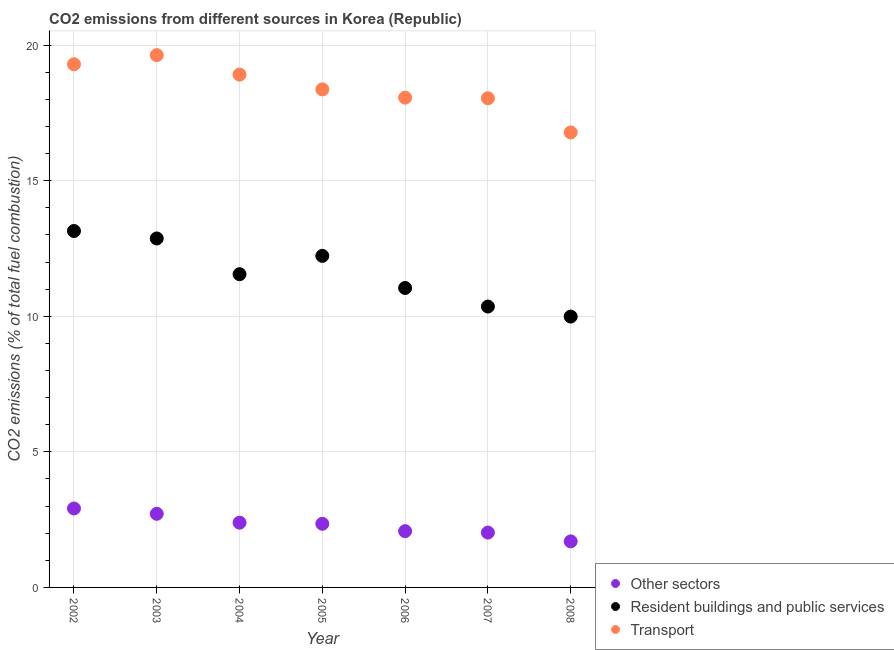How many different coloured dotlines are there?
Keep it short and to the point. 3. What is the percentage of co2 emissions from transport in 2008?
Offer a terse response. 16.78. Across all years, what is the maximum percentage of co2 emissions from transport?
Give a very brief answer. 19.63. Across all years, what is the minimum percentage of co2 emissions from other sectors?
Your answer should be very brief. 1.7. In which year was the percentage of co2 emissions from other sectors minimum?
Your answer should be compact. 2008. What is the total percentage of co2 emissions from transport in the graph?
Provide a short and direct response. 129.08. What is the difference between the percentage of co2 emissions from other sectors in 2006 and that in 2007?
Your answer should be compact. 0.05. What is the difference between the percentage of co2 emissions from other sectors in 2006 and the percentage of co2 emissions from resident buildings and public services in 2005?
Your response must be concise. -10.15. What is the average percentage of co2 emissions from resident buildings and public services per year?
Offer a very short reply. 11.6. In the year 2003, what is the difference between the percentage of co2 emissions from other sectors and percentage of co2 emissions from transport?
Ensure brevity in your answer.  -16.91. In how many years, is the percentage of co2 emissions from other sectors greater than 6 %?
Provide a succinct answer. 0. What is the ratio of the percentage of co2 emissions from resident buildings and public services in 2002 to that in 2005?
Give a very brief answer. 1.07. What is the difference between the highest and the second highest percentage of co2 emissions from other sectors?
Keep it short and to the point. 0.2. What is the difference between the highest and the lowest percentage of co2 emissions from transport?
Provide a succinct answer. 2.85. Is the sum of the percentage of co2 emissions from resident buildings and public services in 2004 and 2006 greater than the maximum percentage of co2 emissions from other sectors across all years?
Give a very brief answer. Yes. Is it the case that in every year, the sum of the percentage of co2 emissions from other sectors and percentage of co2 emissions from resident buildings and public services is greater than the percentage of co2 emissions from transport?
Make the answer very short. No. Is the percentage of co2 emissions from transport strictly greater than the percentage of co2 emissions from other sectors over the years?
Your response must be concise. Yes. How many years are there in the graph?
Provide a short and direct response. 7. How many legend labels are there?
Your answer should be compact. 3. What is the title of the graph?
Your answer should be compact. CO2 emissions from different sources in Korea (Republic). Does "Services" appear as one of the legend labels in the graph?
Your response must be concise. No. What is the label or title of the Y-axis?
Offer a terse response. CO2 emissions (% of total fuel combustion). What is the CO2 emissions (% of total fuel combustion) of Other sectors in 2002?
Offer a terse response. 2.91. What is the CO2 emissions (% of total fuel combustion) in Resident buildings and public services in 2002?
Keep it short and to the point. 13.14. What is the CO2 emissions (% of total fuel combustion) in Transport in 2002?
Your answer should be compact. 19.29. What is the CO2 emissions (% of total fuel combustion) in Other sectors in 2003?
Ensure brevity in your answer.  2.72. What is the CO2 emissions (% of total fuel combustion) of Resident buildings and public services in 2003?
Your answer should be very brief. 12.87. What is the CO2 emissions (% of total fuel combustion) in Transport in 2003?
Offer a terse response. 19.63. What is the CO2 emissions (% of total fuel combustion) in Other sectors in 2004?
Offer a very short reply. 2.39. What is the CO2 emissions (% of total fuel combustion) in Resident buildings and public services in 2004?
Your answer should be compact. 11.55. What is the CO2 emissions (% of total fuel combustion) of Transport in 2004?
Your answer should be compact. 18.91. What is the CO2 emissions (% of total fuel combustion) of Other sectors in 2005?
Keep it short and to the point. 2.35. What is the CO2 emissions (% of total fuel combustion) of Resident buildings and public services in 2005?
Your response must be concise. 12.23. What is the CO2 emissions (% of total fuel combustion) of Transport in 2005?
Your answer should be compact. 18.37. What is the CO2 emissions (% of total fuel combustion) of Other sectors in 2006?
Your response must be concise. 2.07. What is the CO2 emissions (% of total fuel combustion) of Resident buildings and public services in 2006?
Provide a short and direct response. 11.04. What is the CO2 emissions (% of total fuel combustion) of Transport in 2006?
Offer a terse response. 18.06. What is the CO2 emissions (% of total fuel combustion) in Other sectors in 2007?
Keep it short and to the point. 2.02. What is the CO2 emissions (% of total fuel combustion) in Resident buildings and public services in 2007?
Your answer should be very brief. 10.36. What is the CO2 emissions (% of total fuel combustion) of Transport in 2007?
Your answer should be very brief. 18.04. What is the CO2 emissions (% of total fuel combustion) of Other sectors in 2008?
Your answer should be compact. 1.7. What is the CO2 emissions (% of total fuel combustion) in Resident buildings and public services in 2008?
Keep it short and to the point. 9.99. What is the CO2 emissions (% of total fuel combustion) of Transport in 2008?
Your response must be concise. 16.78. Across all years, what is the maximum CO2 emissions (% of total fuel combustion) in Other sectors?
Your answer should be compact. 2.91. Across all years, what is the maximum CO2 emissions (% of total fuel combustion) in Resident buildings and public services?
Provide a succinct answer. 13.14. Across all years, what is the maximum CO2 emissions (% of total fuel combustion) in Transport?
Provide a succinct answer. 19.63. Across all years, what is the minimum CO2 emissions (% of total fuel combustion) in Other sectors?
Make the answer very short. 1.7. Across all years, what is the minimum CO2 emissions (% of total fuel combustion) in Resident buildings and public services?
Your answer should be compact. 9.99. Across all years, what is the minimum CO2 emissions (% of total fuel combustion) in Transport?
Ensure brevity in your answer.  16.78. What is the total CO2 emissions (% of total fuel combustion) in Other sectors in the graph?
Keep it short and to the point. 16.16. What is the total CO2 emissions (% of total fuel combustion) of Resident buildings and public services in the graph?
Provide a succinct answer. 81.18. What is the total CO2 emissions (% of total fuel combustion) in Transport in the graph?
Offer a terse response. 129.08. What is the difference between the CO2 emissions (% of total fuel combustion) in Other sectors in 2002 and that in 2003?
Make the answer very short. 0.2. What is the difference between the CO2 emissions (% of total fuel combustion) in Resident buildings and public services in 2002 and that in 2003?
Give a very brief answer. 0.28. What is the difference between the CO2 emissions (% of total fuel combustion) in Transport in 2002 and that in 2003?
Your response must be concise. -0.34. What is the difference between the CO2 emissions (% of total fuel combustion) of Other sectors in 2002 and that in 2004?
Ensure brevity in your answer.  0.52. What is the difference between the CO2 emissions (% of total fuel combustion) in Resident buildings and public services in 2002 and that in 2004?
Provide a succinct answer. 1.59. What is the difference between the CO2 emissions (% of total fuel combustion) in Transport in 2002 and that in 2004?
Give a very brief answer. 0.38. What is the difference between the CO2 emissions (% of total fuel combustion) of Other sectors in 2002 and that in 2005?
Keep it short and to the point. 0.56. What is the difference between the CO2 emissions (% of total fuel combustion) of Resident buildings and public services in 2002 and that in 2005?
Your response must be concise. 0.92. What is the difference between the CO2 emissions (% of total fuel combustion) of Transport in 2002 and that in 2005?
Provide a succinct answer. 0.93. What is the difference between the CO2 emissions (% of total fuel combustion) in Other sectors in 2002 and that in 2006?
Your answer should be compact. 0.84. What is the difference between the CO2 emissions (% of total fuel combustion) of Resident buildings and public services in 2002 and that in 2006?
Make the answer very short. 2.1. What is the difference between the CO2 emissions (% of total fuel combustion) of Transport in 2002 and that in 2006?
Make the answer very short. 1.23. What is the difference between the CO2 emissions (% of total fuel combustion) in Other sectors in 2002 and that in 2007?
Give a very brief answer. 0.89. What is the difference between the CO2 emissions (% of total fuel combustion) of Resident buildings and public services in 2002 and that in 2007?
Ensure brevity in your answer.  2.79. What is the difference between the CO2 emissions (% of total fuel combustion) of Transport in 2002 and that in 2007?
Provide a short and direct response. 1.25. What is the difference between the CO2 emissions (% of total fuel combustion) of Other sectors in 2002 and that in 2008?
Offer a terse response. 1.21. What is the difference between the CO2 emissions (% of total fuel combustion) of Resident buildings and public services in 2002 and that in 2008?
Make the answer very short. 3.16. What is the difference between the CO2 emissions (% of total fuel combustion) in Transport in 2002 and that in 2008?
Make the answer very short. 2.51. What is the difference between the CO2 emissions (% of total fuel combustion) of Other sectors in 2003 and that in 2004?
Offer a very short reply. 0.33. What is the difference between the CO2 emissions (% of total fuel combustion) of Resident buildings and public services in 2003 and that in 2004?
Keep it short and to the point. 1.32. What is the difference between the CO2 emissions (% of total fuel combustion) in Transport in 2003 and that in 2004?
Your answer should be compact. 0.72. What is the difference between the CO2 emissions (% of total fuel combustion) in Other sectors in 2003 and that in 2005?
Your answer should be very brief. 0.37. What is the difference between the CO2 emissions (% of total fuel combustion) of Resident buildings and public services in 2003 and that in 2005?
Your answer should be very brief. 0.64. What is the difference between the CO2 emissions (% of total fuel combustion) in Transport in 2003 and that in 2005?
Offer a very short reply. 1.26. What is the difference between the CO2 emissions (% of total fuel combustion) in Other sectors in 2003 and that in 2006?
Make the answer very short. 0.64. What is the difference between the CO2 emissions (% of total fuel combustion) of Resident buildings and public services in 2003 and that in 2006?
Make the answer very short. 1.83. What is the difference between the CO2 emissions (% of total fuel combustion) in Transport in 2003 and that in 2006?
Give a very brief answer. 1.57. What is the difference between the CO2 emissions (% of total fuel combustion) of Other sectors in 2003 and that in 2007?
Your answer should be compact. 0.69. What is the difference between the CO2 emissions (% of total fuel combustion) in Resident buildings and public services in 2003 and that in 2007?
Offer a very short reply. 2.51. What is the difference between the CO2 emissions (% of total fuel combustion) of Transport in 2003 and that in 2007?
Your answer should be very brief. 1.59. What is the difference between the CO2 emissions (% of total fuel combustion) in Other sectors in 2003 and that in 2008?
Give a very brief answer. 1.02. What is the difference between the CO2 emissions (% of total fuel combustion) in Resident buildings and public services in 2003 and that in 2008?
Provide a short and direct response. 2.88. What is the difference between the CO2 emissions (% of total fuel combustion) of Transport in 2003 and that in 2008?
Your response must be concise. 2.85. What is the difference between the CO2 emissions (% of total fuel combustion) of Other sectors in 2004 and that in 2005?
Offer a very short reply. 0.04. What is the difference between the CO2 emissions (% of total fuel combustion) in Resident buildings and public services in 2004 and that in 2005?
Ensure brevity in your answer.  -0.68. What is the difference between the CO2 emissions (% of total fuel combustion) in Transport in 2004 and that in 2005?
Your response must be concise. 0.55. What is the difference between the CO2 emissions (% of total fuel combustion) of Other sectors in 2004 and that in 2006?
Give a very brief answer. 0.31. What is the difference between the CO2 emissions (% of total fuel combustion) in Resident buildings and public services in 2004 and that in 2006?
Offer a very short reply. 0.51. What is the difference between the CO2 emissions (% of total fuel combustion) of Transport in 2004 and that in 2006?
Your answer should be very brief. 0.85. What is the difference between the CO2 emissions (% of total fuel combustion) in Other sectors in 2004 and that in 2007?
Provide a succinct answer. 0.37. What is the difference between the CO2 emissions (% of total fuel combustion) in Resident buildings and public services in 2004 and that in 2007?
Your response must be concise. 1.19. What is the difference between the CO2 emissions (% of total fuel combustion) in Transport in 2004 and that in 2007?
Offer a terse response. 0.87. What is the difference between the CO2 emissions (% of total fuel combustion) of Other sectors in 2004 and that in 2008?
Your answer should be compact. 0.69. What is the difference between the CO2 emissions (% of total fuel combustion) in Resident buildings and public services in 2004 and that in 2008?
Make the answer very short. 1.56. What is the difference between the CO2 emissions (% of total fuel combustion) of Transport in 2004 and that in 2008?
Your answer should be compact. 2.13. What is the difference between the CO2 emissions (% of total fuel combustion) in Other sectors in 2005 and that in 2006?
Offer a very short reply. 0.27. What is the difference between the CO2 emissions (% of total fuel combustion) of Resident buildings and public services in 2005 and that in 2006?
Your answer should be compact. 1.18. What is the difference between the CO2 emissions (% of total fuel combustion) of Transport in 2005 and that in 2006?
Your answer should be very brief. 0.3. What is the difference between the CO2 emissions (% of total fuel combustion) in Other sectors in 2005 and that in 2007?
Your answer should be very brief. 0.32. What is the difference between the CO2 emissions (% of total fuel combustion) in Resident buildings and public services in 2005 and that in 2007?
Make the answer very short. 1.87. What is the difference between the CO2 emissions (% of total fuel combustion) in Transport in 2005 and that in 2007?
Provide a succinct answer. 0.33. What is the difference between the CO2 emissions (% of total fuel combustion) in Other sectors in 2005 and that in 2008?
Your answer should be compact. 0.65. What is the difference between the CO2 emissions (% of total fuel combustion) in Resident buildings and public services in 2005 and that in 2008?
Provide a short and direct response. 2.24. What is the difference between the CO2 emissions (% of total fuel combustion) of Transport in 2005 and that in 2008?
Offer a very short reply. 1.59. What is the difference between the CO2 emissions (% of total fuel combustion) of Other sectors in 2006 and that in 2007?
Give a very brief answer. 0.05. What is the difference between the CO2 emissions (% of total fuel combustion) in Resident buildings and public services in 2006 and that in 2007?
Offer a terse response. 0.68. What is the difference between the CO2 emissions (% of total fuel combustion) of Transport in 2006 and that in 2007?
Your response must be concise. 0.02. What is the difference between the CO2 emissions (% of total fuel combustion) of Other sectors in 2006 and that in 2008?
Keep it short and to the point. 0.38. What is the difference between the CO2 emissions (% of total fuel combustion) in Resident buildings and public services in 2006 and that in 2008?
Your answer should be compact. 1.05. What is the difference between the CO2 emissions (% of total fuel combustion) in Transport in 2006 and that in 2008?
Provide a succinct answer. 1.28. What is the difference between the CO2 emissions (% of total fuel combustion) of Other sectors in 2007 and that in 2008?
Provide a short and direct response. 0.32. What is the difference between the CO2 emissions (% of total fuel combustion) in Resident buildings and public services in 2007 and that in 2008?
Your answer should be very brief. 0.37. What is the difference between the CO2 emissions (% of total fuel combustion) of Transport in 2007 and that in 2008?
Make the answer very short. 1.26. What is the difference between the CO2 emissions (% of total fuel combustion) in Other sectors in 2002 and the CO2 emissions (% of total fuel combustion) in Resident buildings and public services in 2003?
Your response must be concise. -9.96. What is the difference between the CO2 emissions (% of total fuel combustion) of Other sectors in 2002 and the CO2 emissions (% of total fuel combustion) of Transport in 2003?
Ensure brevity in your answer.  -16.72. What is the difference between the CO2 emissions (% of total fuel combustion) of Resident buildings and public services in 2002 and the CO2 emissions (% of total fuel combustion) of Transport in 2003?
Ensure brevity in your answer.  -6.49. What is the difference between the CO2 emissions (% of total fuel combustion) of Other sectors in 2002 and the CO2 emissions (% of total fuel combustion) of Resident buildings and public services in 2004?
Give a very brief answer. -8.64. What is the difference between the CO2 emissions (% of total fuel combustion) in Other sectors in 2002 and the CO2 emissions (% of total fuel combustion) in Transport in 2004?
Your answer should be compact. -16. What is the difference between the CO2 emissions (% of total fuel combustion) in Resident buildings and public services in 2002 and the CO2 emissions (% of total fuel combustion) in Transport in 2004?
Your answer should be compact. -5.77. What is the difference between the CO2 emissions (% of total fuel combustion) of Other sectors in 2002 and the CO2 emissions (% of total fuel combustion) of Resident buildings and public services in 2005?
Offer a terse response. -9.32. What is the difference between the CO2 emissions (% of total fuel combustion) in Other sectors in 2002 and the CO2 emissions (% of total fuel combustion) in Transport in 2005?
Your answer should be compact. -15.45. What is the difference between the CO2 emissions (% of total fuel combustion) of Resident buildings and public services in 2002 and the CO2 emissions (% of total fuel combustion) of Transport in 2005?
Provide a short and direct response. -5.22. What is the difference between the CO2 emissions (% of total fuel combustion) of Other sectors in 2002 and the CO2 emissions (% of total fuel combustion) of Resident buildings and public services in 2006?
Your answer should be compact. -8.13. What is the difference between the CO2 emissions (% of total fuel combustion) in Other sectors in 2002 and the CO2 emissions (% of total fuel combustion) in Transport in 2006?
Provide a short and direct response. -15.15. What is the difference between the CO2 emissions (% of total fuel combustion) in Resident buildings and public services in 2002 and the CO2 emissions (% of total fuel combustion) in Transport in 2006?
Your answer should be compact. -4.92. What is the difference between the CO2 emissions (% of total fuel combustion) of Other sectors in 2002 and the CO2 emissions (% of total fuel combustion) of Resident buildings and public services in 2007?
Keep it short and to the point. -7.45. What is the difference between the CO2 emissions (% of total fuel combustion) of Other sectors in 2002 and the CO2 emissions (% of total fuel combustion) of Transport in 2007?
Your answer should be very brief. -15.13. What is the difference between the CO2 emissions (% of total fuel combustion) of Resident buildings and public services in 2002 and the CO2 emissions (% of total fuel combustion) of Transport in 2007?
Give a very brief answer. -4.9. What is the difference between the CO2 emissions (% of total fuel combustion) in Other sectors in 2002 and the CO2 emissions (% of total fuel combustion) in Resident buildings and public services in 2008?
Your answer should be very brief. -7.08. What is the difference between the CO2 emissions (% of total fuel combustion) of Other sectors in 2002 and the CO2 emissions (% of total fuel combustion) of Transport in 2008?
Give a very brief answer. -13.87. What is the difference between the CO2 emissions (% of total fuel combustion) of Resident buildings and public services in 2002 and the CO2 emissions (% of total fuel combustion) of Transport in 2008?
Your answer should be compact. -3.63. What is the difference between the CO2 emissions (% of total fuel combustion) of Other sectors in 2003 and the CO2 emissions (% of total fuel combustion) of Resident buildings and public services in 2004?
Keep it short and to the point. -8.84. What is the difference between the CO2 emissions (% of total fuel combustion) of Other sectors in 2003 and the CO2 emissions (% of total fuel combustion) of Transport in 2004?
Your answer should be compact. -16.2. What is the difference between the CO2 emissions (% of total fuel combustion) in Resident buildings and public services in 2003 and the CO2 emissions (% of total fuel combustion) in Transport in 2004?
Offer a terse response. -6.04. What is the difference between the CO2 emissions (% of total fuel combustion) of Other sectors in 2003 and the CO2 emissions (% of total fuel combustion) of Resident buildings and public services in 2005?
Make the answer very short. -9.51. What is the difference between the CO2 emissions (% of total fuel combustion) in Other sectors in 2003 and the CO2 emissions (% of total fuel combustion) in Transport in 2005?
Keep it short and to the point. -15.65. What is the difference between the CO2 emissions (% of total fuel combustion) in Resident buildings and public services in 2003 and the CO2 emissions (% of total fuel combustion) in Transport in 2005?
Make the answer very short. -5.5. What is the difference between the CO2 emissions (% of total fuel combustion) of Other sectors in 2003 and the CO2 emissions (% of total fuel combustion) of Resident buildings and public services in 2006?
Ensure brevity in your answer.  -8.33. What is the difference between the CO2 emissions (% of total fuel combustion) in Other sectors in 2003 and the CO2 emissions (% of total fuel combustion) in Transport in 2006?
Your answer should be compact. -15.35. What is the difference between the CO2 emissions (% of total fuel combustion) of Resident buildings and public services in 2003 and the CO2 emissions (% of total fuel combustion) of Transport in 2006?
Make the answer very short. -5.19. What is the difference between the CO2 emissions (% of total fuel combustion) of Other sectors in 2003 and the CO2 emissions (% of total fuel combustion) of Resident buildings and public services in 2007?
Make the answer very short. -7.64. What is the difference between the CO2 emissions (% of total fuel combustion) of Other sectors in 2003 and the CO2 emissions (% of total fuel combustion) of Transport in 2007?
Make the answer very short. -15.32. What is the difference between the CO2 emissions (% of total fuel combustion) in Resident buildings and public services in 2003 and the CO2 emissions (% of total fuel combustion) in Transport in 2007?
Offer a terse response. -5.17. What is the difference between the CO2 emissions (% of total fuel combustion) in Other sectors in 2003 and the CO2 emissions (% of total fuel combustion) in Resident buildings and public services in 2008?
Offer a very short reply. -7.27. What is the difference between the CO2 emissions (% of total fuel combustion) in Other sectors in 2003 and the CO2 emissions (% of total fuel combustion) in Transport in 2008?
Offer a terse response. -14.06. What is the difference between the CO2 emissions (% of total fuel combustion) of Resident buildings and public services in 2003 and the CO2 emissions (% of total fuel combustion) of Transport in 2008?
Offer a very short reply. -3.91. What is the difference between the CO2 emissions (% of total fuel combustion) in Other sectors in 2004 and the CO2 emissions (% of total fuel combustion) in Resident buildings and public services in 2005?
Provide a succinct answer. -9.84. What is the difference between the CO2 emissions (% of total fuel combustion) of Other sectors in 2004 and the CO2 emissions (% of total fuel combustion) of Transport in 2005?
Make the answer very short. -15.98. What is the difference between the CO2 emissions (% of total fuel combustion) in Resident buildings and public services in 2004 and the CO2 emissions (% of total fuel combustion) in Transport in 2005?
Your response must be concise. -6.82. What is the difference between the CO2 emissions (% of total fuel combustion) in Other sectors in 2004 and the CO2 emissions (% of total fuel combustion) in Resident buildings and public services in 2006?
Ensure brevity in your answer.  -8.65. What is the difference between the CO2 emissions (% of total fuel combustion) in Other sectors in 2004 and the CO2 emissions (% of total fuel combustion) in Transport in 2006?
Your answer should be compact. -15.67. What is the difference between the CO2 emissions (% of total fuel combustion) of Resident buildings and public services in 2004 and the CO2 emissions (% of total fuel combustion) of Transport in 2006?
Make the answer very short. -6.51. What is the difference between the CO2 emissions (% of total fuel combustion) of Other sectors in 2004 and the CO2 emissions (% of total fuel combustion) of Resident buildings and public services in 2007?
Keep it short and to the point. -7.97. What is the difference between the CO2 emissions (% of total fuel combustion) in Other sectors in 2004 and the CO2 emissions (% of total fuel combustion) in Transport in 2007?
Make the answer very short. -15.65. What is the difference between the CO2 emissions (% of total fuel combustion) in Resident buildings and public services in 2004 and the CO2 emissions (% of total fuel combustion) in Transport in 2007?
Make the answer very short. -6.49. What is the difference between the CO2 emissions (% of total fuel combustion) of Other sectors in 2004 and the CO2 emissions (% of total fuel combustion) of Resident buildings and public services in 2008?
Offer a very short reply. -7.6. What is the difference between the CO2 emissions (% of total fuel combustion) in Other sectors in 2004 and the CO2 emissions (% of total fuel combustion) in Transport in 2008?
Provide a short and direct response. -14.39. What is the difference between the CO2 emissions (% of total fuel combustion) of Resident buildings and public services in 2004 and the CO2 emissions (% of total fuel combustion) of Transport in 2008?
Offer a terse response. -5.23. What is the difference between the CO2 emissions (% of total fuel combustion) of Other sectors in 2005 and the CO2 emissions (% of total fuel combustion) of Resident buildings and public services in 2006?
Offer a terse response. -8.7. What is the difference between the CO2 emissions (% of total fuel combustion) of Other sectors in 2005 and the CO2 emissions (% of total fuel combustion) of Transport in 2006?
Provide a short and direct response. -15.72. What is the difference between the CO2 emissions (% of total fuel combustion) of Resident buildings and public services in 2005 and the CO2 emissions (% of total fuel combustion) of Transport in 2006?
Provide a short and direct response. -5.83. What is the difference between the CO2 emissions (% of total fuel combustion) of Other sectors in 2005 and the CO2 emissions (% of total fuel combustion) of Resident buildings and public services in 2007?
Keep it short and to the point. -8.01. What is the difference between the CO2 emissions (% of total fuel combustion) of Other sectors in 2005 and the CO2 emissions (% of total fuel combustion) of Transport in 2007?
Ensure brevity in your answer.  -15.69. What is the difference between the CO2 emissions (% of total fuel combustion) in Resident buildings and public services in 2005 and the CO2 emissions (% of total fuel combustion) in Transport in 2007?
Your answer should be very brief. -5.81. What is the difference between the CO2 emissions (% of total fuel combustion) of Other sectors in 2005 and the CO2 emissions (% of total fuel combustion) of Resident buildings and public services in 2008?
Your answer should be compact. -7.64. What is the difference between the CO2 emissions (% of total fuel combustion) of Other sectors in 2005 and the CO2 emissions (% of total fuel combustion) of Transport in 2008?
Your answer should be very brief. -14.43. What is the difference between the CO2 emissions (% of total fuel combustion) in Resident buildings and public services in 2005 and the CO2 emissions (% of total fuel combustion) in Transport in 2008?
Your response must be concise. -4.55. What is the difference between the CO2 emissions (% of total fuel combustion) of Other sectors in 2006 and the CO2 emissions (% of total fuel combustion) of Resident buildings and public services in 2007?
Offer a terse response. -8.28. What is the difference between the CO2 emissions (% of total fuel combustion) of Other sectors in 2006 and the CO2 emissions (% of total fuel combustion) of Transport in 2007?
Your response must be concise. -15.96. What is the difference between the CO2 emissions (% of total fuel combustion) of Resident buildings and public services in 2006 and the CO2 emissions (% of total fuel combustion) of Transport in 2007?
Keep it short and to the point. -7. What is the difference between the CO2 emissions (% of total fuel combustion) of Other sectors in 2006 and the CO2 emissions (% of total fuel combustion) of Resident buildings and public services in 2008?
Make the answer very short. -7.91. What is the difference between the CO2 emissions (% of total fuel combustion) in Other sectors in 2006 and the CO2 emissions (% of total fuel combustion) in Transport in 2008?
Ensure brevity in your answer.  -14.7. What is the difference between the CO2 emissions (% of total fuel combustion) of Resident buildings and public services in 2006 and the CO2 emissions (% of total fuel combustion) of Transport in 2008?
Your response must be concise. -5.74. What is the difference between the CO2 emissions (% of total fuel combustion) of Other sectors in 2007 and the CO2 emissions (% of total fuel combustion) of Resident buildings and public services in 2008?
Provide a succinct answer. -7.97. What is the difference between the CO2 emissions (% of total fuel combustion) in Other sectors in 2007 and the CO2 emissions (% of total fuel combustion) in Transport in 2008?
Offer a terse response. -14.76. What is the difference between the CO2 emissions (% of total fuel combustion) in Resident buildings and public services in 2007 and the CO2 emissions (% of total fuel combustion) in Transport in 2008?
Your response must be concise. -6.42. What is the average CO2 emissions (% of total fuel combustion) in Other sectors per year?
Offer a terse response. 2.31. What is the average CO2 emissions (% of total fuel combustion) of Resident buildings and public services per year?
Offer a terse response. 11.6. What is the average CO2 emissions (% of total fuel combustion) in Transport per year?
Make the answer very short. 18.44. In the year 2002, what is the difference between the CO2 emissions (% of total fuel combustion) in Other sectors and CO2 emissions (% of total fuel combustion) in Resident buildings and public services?
Provide a short and direct response. -10.23. In the year 2002, what is the difference between the CO2 emissions (% of total fuel combustion) in Other sectors and CO2 emissions (% of total fuel combustion) in Transport?
Offer a terse response. -16.38. In the year 2002, what is the difference between the CO2 emissions (% of total fuel combustion) in Resident buildings and public services and CO2 emissions (% of total fuel combustion) in Transport?
Offer a terse response. -6.15. In the year 2003, what is the difference between the CO2 emissions (% of total fuel combustion) in Other sectors and CO2 emissions (% of total fuel combustion) in Resident buildings and public services?
Ensure brevity in your answer.  -10.15. In the year 2003, what is the difference between the CO2 emissions (% of total fuel combustion) in Other sectors and CO2 emissions (% of total fuel combustion) in Transport?
Your answer should be very brief. -16.91. In the year 2003, what is the difference between the CO2 emissions (% of total fuel combustion) in Resident buildings and public services and CO2 emissions (% of total fuel combustion) in Transport?
Keep it short and to the point. -6.76. In the year 2004, what is the difference between the CO2 emissions (% of total fuel combustion) in Other sectors and CO2 emissions (% of total fuel combustion) in Resident buildings and public services?
Your response must be concise. -9.16. In the year 2004, what is the difference between the CO2 emissions (% of total fuel combustion) of Other sectors and CO2 emissions (% of total fuel combustion) of Transport?
Ensure brevity in your answer.  -16.52. In the year 2004, what is the difference between the CO2 emissions (% of total fuel combustion) of Resident buildings and public services and CO2 emissions (% of total fuel combustion) of Transport?
Keep it short and to the point. -7.36. In the year 2005, what is the difference between the CO2 emissions (% of total fuel combustion) in Other sectors and CO2 emissions (% of total fuel combustion) in Resident buildings and public services?
Offer a very short reply. -9.88. In the year 2005, what is the difference between the CO2 emissions (% of total fuel combustion) in Other sectors and CO2 emissions (% of total fuel combustion) in Transport?
Ensure brevity in your answer.  -16.02. In the year 2005, what is the difference between the CO2 emissions (% of total fuel combustion) in Resident buildings and public services and CO2 emissions (% of total fuel combustion) in Transport?
Your answer should be compact. -6.14. In the year 2006, what is the difference between the CO2 emissions (% of total fuel combustion) of Other sectors and CO2 emissions (% of total fuel combustion) of Resident buildings and public services?
Ensure brevity in your answer.  -8.97. In the year 2006, what is the difference between the CO2 emissions (% of total fuel combustion) of Other sectors and CO2 emissions (% of total fuel combustion) of Transport?
Keep it short and to the point. -15.99. In the year 2006, what is the difference between the CO2 emissions (% of total fuel combustion) in Resident buildings and public services and CO2 emissions (% of total fuel combustion) in Transport?
Your answer should be compact. -7.02. In the year 2007, what is the difference between the CO2 emissions (% of total fuel combustion) of Other sectors and CO2 emissions (% of total fuel combustion) of Resident buildings and public services?
Your answer should be compact. -8.34. In the year 2007, what is the difference between the CO2 emissions (% of total fuel combustion) in Other sectors and CO2 emissions (% of total fuel combustion) in Transport?
Offer a very short reply. -16.02. In the year 2007, what is the difference between the CO2 emissions (% of total fuel combustion) of Resident buildings and public services and CO2 emissions (% of total fuel combustion) of Transport?
Your answer should be compact. -7.68. In the year 2008, what is the difference between the CO2 emissions (% of total fuel combustion) of Other sectors and CO2 emissions (% of total fuel combustion) of Resident buildings and public services?
Your answer should be compact. -8.29. In the year 2008, what is the difference between the CO2 emissions (% of total fuel combustion) in Other sectors and CO2 emissions (% of total fuel combustion) in Transport?
Your answer should be compact. -15.08. In the year 2008, what is the difference between the CO2 emissions (% of total fuel combustion) in Resident buildings and public services and CO2 emissions (% of total fuel combustion) in Transport?
Make the answer very short. -6.79. What is the ratio of the CO2 emissions (% of total fuel combustion) of Other sectors in 2002 to that in 2003?
Your answer should be compact. 1.07. What is the ratio of the CO2 emissions (% of total fuel combustion) in Resident buildings and public services in 2002 to that in 2003?
Your answer should be very brief. 1.02. What is the ratio of the CO2 emissions (% of total fuel combustion) of Transport in 2002 to that in 2003?
Offer a terse response. 0.98. What is the ratio of the CO2 emissions (% of total fuel combustion) in Other sectors in 2002 to that in 2004?
Ensure brevity in your answer.  1.22. What is the ratio of the CO2 emissions (% of total fuel combustion) in Resident buildings and public services in 2002 to that in 2004?
Offer a terse response. 1.14. What is the ratio of the CO2 emissions (% of total fuel combustion) in Transport in 2002 to that in 2004?
Provide a short and direct response. 1.02. What is the ratio of the CO2 emissions (% of total fuel combustion) of Other sectors in 2002 to that in 2005?
Offer a terse response. 1.24. What is the ratio of the CO2 emissions (% of total fuel combustion) in Resident buildings and public services in 2002 to that in 2005?
Your answer should be compact. 1.07. What is the ratio of the CO2 emissions (% of total fuel combustion) in Transport in 2002 to that in 2005?
Provide a succinct answer. 1.05. What is the ratio of the CO2 emissions (% of total fuel combustion) of Other sectors in 2002 to that in 2006?
Your response must be concise. 1.4. What is the ratio of the CO2 emissions (% of total fuel combustion) of Resident buildings and public services in 2002 to that in 2006?
Provide a short and direct response. 1.19. What is the ratio of the CO2 emissions (% of total fuel combustion) in Transport in 2002 to that in 2006?
Your response must be concise. 1.07. What is the ratio of the CO2 emissions (% of total fuel combustion) in Other sectors in 2002 to that in 2007?
Offer a terse response. 1.44. What is the ratio of the CO2 emissions (% of total fuel combustion) of Resident buildings and public services in 2002 to that in 2007?
Provide a succinct answer. 1.27. What is the ratio of the CO2 emissions (% of total fuel combustion) of Transport in 2002 to that in 2007?
Ensure brevity in your answer.  1.07. What is the ratio of the CO2 emissions (% of total fuel combustion) in Other sectors in 2002 to that in 2008?
Your response must be concise. 1.71. What is the ratio of the CO2 emissions (% of total fuel combustion) in Resident buildings and public services in 2002 to that in 2008?
Your answer should be very brief. 1.32. What is the ratio of the CO2 emissions (% of total fuel combustion) in Transport in 2002 to that in 2008?
Keep it short and to the point. 1.15. What is the ratio of the CO2 emissions (% of total fuel combustion) of Other sectors in 2003 to that in 2004?
Your response must be concise. 1.14. What is the ratio of the CO2 emissions (% of total fuel combustion) in Resident buildings and public services in 2003 to that in 2004?
Provide a short and direct response. 1.11. What is the ratio of the CO2 emissions (% of total fuel combustion) of Transport in 2003 to that in 2004?
Provide a short and direct response. 1.04. What is the ratio of the CO2 emissions (% of total fuel combustion) of Other sectors in 2003 to that in 2005?
Offer a terse response. 1.16. What is the ratio of the CO2 emissions (% of total fuel combustion) of Resident buildings and public services in 2003 to that in 2005?
Ensure brevity in your answer.  1.05. What is the ratio of the CO2 emissions (% of total fuel combustion) in Transport in 2003 to that in 2005?
Offer a very short reply. 1.07. What is the ratio of the CO2 emissions (% of total fuel combustion) of Other sectors in 2003 to that in 2006?
Offer a very short reply. 1.31. What is the ratio of the CO2 emissions (% of total fuel combustion) of Resident buildings and public services in 2003 to that in 2006?
Ensure brevity in your answer.  1.17. What is the ratio of the CO2 emissions (% of total fuel combustion) in Transport in 2003 to that in 2006?
Your answer should be compact. 1.09. What is the ratio of the CO2 emissions (% of total fuel combustion) of Other sectors in 2003 to that in 2007?
Offer a very short reply. 1.34. What is the ratio of the CO2 emissions (% of total fuel combustion) of Resident buildings and public services in 2003 to that in 2007?
Offer a very short reply. 1.24. What is the ratio of the CO2 emissions (% of total fuel combustion) of Transport in 2003 to that in 2007?
Keep it short and to the point. 1.09. What is the ratio of the CO2 emissions (% of total fuel combustion) in Other sectors in 2003 to that in 2008?
Provide a succinct answer. 1.6. What is the ratio of the CO2 emissions (% of total fuel combustion) of Resident buildings and public services in 2003 to that in 2008?
Give a very brief answer. 1.29. What is the ratio of the CO2 emissions (% of total fuel combustion) in Transport in 2003 to that in 2008?
Offer a very short reply. 1.17. What is the ratio of the CO2 emissions (% of total fuel combustion) in Other sectors in 2004 to that in 2005?
Offer a terse response. 1.02. What is the ratio of the CO2 emissions (% of total fuel combustion) of Resident buildings and public services in 2004 to that in 2005?
Ensure brevity in your answer.  0.94. What is the ratio of the CO2 emissions (% of total fuel combustion) in Transport in 2004 to that in 2005?
Your response must be concise. 1.03. What is the ratio of the CO2 emissions (% of total fuel combustion) of Other sectors in 2004 to that in 2006?
Your answer should be compact. 1.15. What is the ratio of the CO2 emissions (% of total fuel combustion) of Resident buildings and public services in 2004 to that in 2006?
Make the answer very short. 1.05. What is the ratio of the CO2 emissions (% of total fuel combustion) in Transport in 2004 to that in 2006?
Provide a succinct answer. 1.05. What is the ratio of the CO2 emissions (% of total fuel combustion) of Other sectors in 2004 to that in 2007?
Provide a succinct answer. 1.18. What is the ratio of the CO2 emissions (% of total fuel combustion) of Resident buildings and public services in 2004 to that in 2007?
Give a very brief answer. 1.12. What is the ratio of the CO2 emissions (% of total fuel combustion) of Transport in 2004 to that in 2007?
Your response must be concise. 1.05. What is the ratio of the CO2 emissions (% of total fuel combustion) in Other sectors in 2004 to that in 2008?
Your response must be concise. 1.41. What is the ratio of the CO2 emissions (% of total fuel combustion) in Resident buildings and public services in 2004 to that in 2008?
Offer a terse response. 1.16. What is the ratio of the CO2 emissions (% of total fuel combustion) of Transport in 2004 to that in 2008?
Your answer should be very brief. 1.13. What is the ratio of the CO2 emissions (% of total fuel combustion) in Other sectors in 2005 to that in 2006?
Provide a short and direct response. 1.13. What is the ratio of the CO2 emissions (% of total fuel combustion) of Resident buildings and public services in 2005 to that in 2006?
Provide a succinct answer. 1.11. What is the ratio of the CO2 emissions (% of total fuel combustion) of Transport in 2005 to that in 2006?
Offer a very short reply. 1.02. What is the ratio of the CO2 emissions (% of total fuel combustion) of Other sectors in 2005 to that in 2007?
Ensure brevity in your answer.  1.16. What is the ratio of the CO2 emissions (% of total fuel combustion) in Resident buildings and public services in 2005 to that in 2007?
Keep it short and to the point. 1.18. What is the ratio of the CO2 emissions (% of total fuel combustion) of Transport in 2005 to that in 2007?
Keep it short and to the point. 1.02. What is the ratio of the CO2 emissions (% of total fuel combustion) of Other sectors in 2005 to that in 2008?
Your answer should be compact. 1.38. What is the ratio of the CO2 emissions (% of total fuel combustion) in Resident buildings and public services in 2005 to that in 2008?
Your response must be concise. 1.22. What is the ratio of the CO2 emissions (% of total fuel combustion) of Transport in 2005 to that in 2008?
Your response must be concise. 1.09. What is the ratio of the CO2 emissions (% of total fuel combustion) of Other sectors in 2006 to that in 2007?
Your answer should be very brief. 1.03. What is the ratio of the CO2 emissions (% of total fuel combustion) in Resident buildings and public services in 2006 to that in 2007?
Make the answer very short. 1.07. What is the ratio of the CO2 emissions (% of total fuel combustion) of Other sectors in 2006 to that in 2008?
Offer a very short reply. 1.22. What is the ratio of the CO2 emissions (% of total fuel combustion) in Resident buildings and public services in 2006 to that in 2008?
Your answer should be compact. 1.11. What is the ratio of the CO2 emissions (% of total fuel combustion) in Transport in 2006 to that in 2008?
Your answer should be compact. 1.08. What is the ratio of the CO2 emissions (% of total fuel combustion) of Other sectors in 2007 to that in 2008?
Provide a succinct answer. 1.19. What is the ratio of the CO2 emissions (% of total fuel combustion) of Resident buildings and public services in 2007 to that in 2008?
Ensure brevity in your answer.  1.04. What is the ratio of the CO2 emissions (% of total fuel combustion) of Transport in 2007 to that in 2008?
Your answer should be compact. 1.08. What is the difference between the highest and the second highest CO2 emissions (% of total fuel combustion) in Other sectors?
Your response must be concise. 0.2. What is the difference between the highest and the second highest CO2 emissions (% of total fuel combustion) in Resident buildings and public services?
Give a very brief answer. 0.28. What is the difference between the highest and the second highest CO2 emissions (% of total fuel combustion) of Transport?
Give a very brief answer. 0.34. What is the difference between the highest and the lowest CO2 emissions (% of total fuel combustion) in Other sectors?
Offer a terse response. 1.21. What is the difference between the highest and the lowest CO2 emissions (% of total fuel combustion) of Resident buildings and public services?
Your response must be concise. 3.16. What is the difference between the highest and the lowest CO2 emissions (% of total fuel combustion) of Transport?
Your response must be concise. 2.85. 